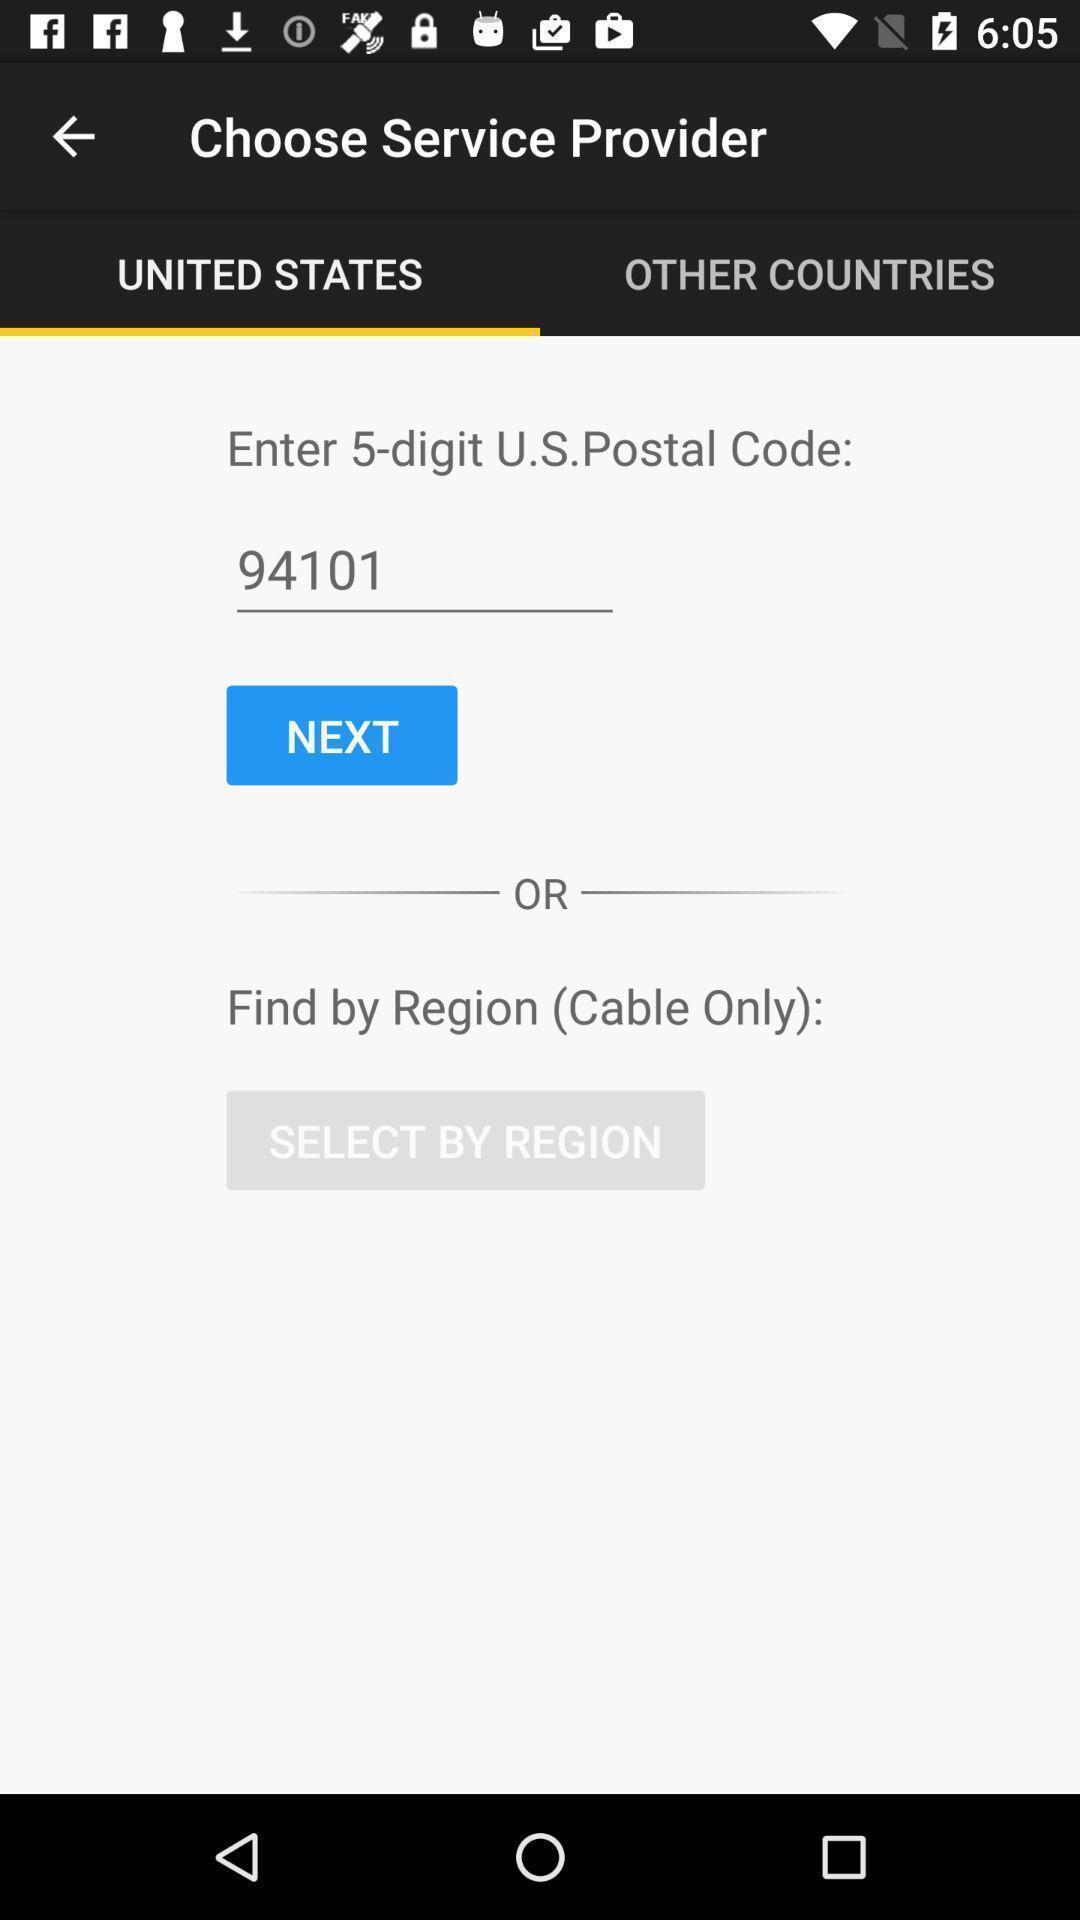Describe the key features of this screenshot. Page showing enter 5-digit u.s.postal code. 